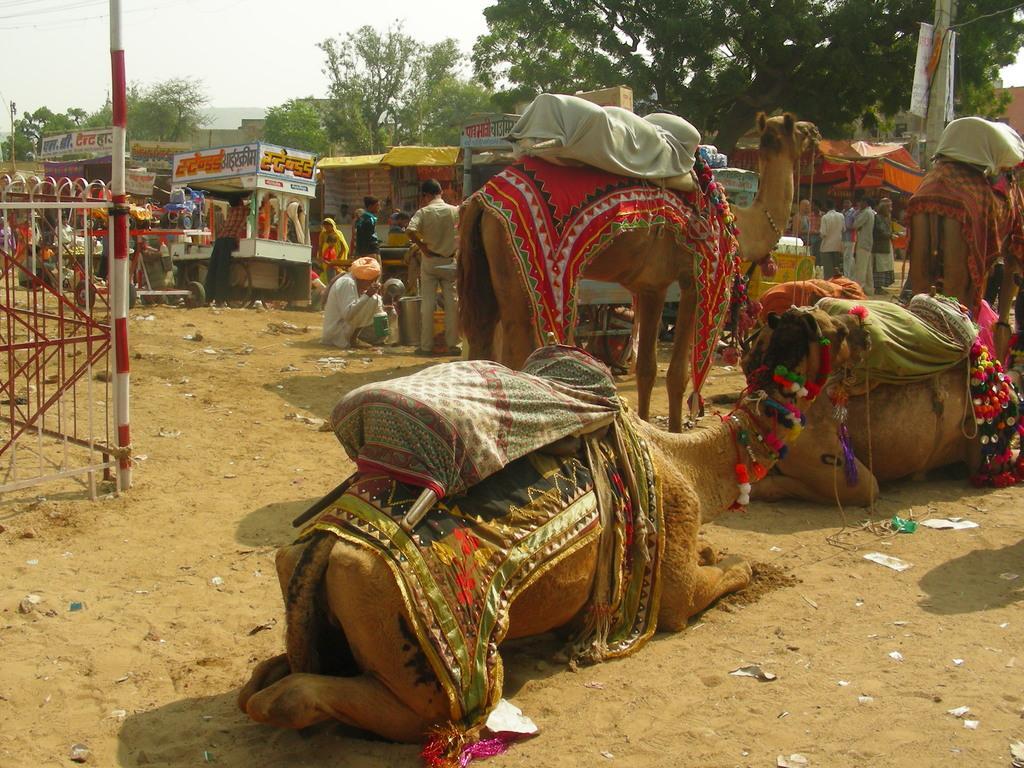In one or two sentences, can you explain what this image depicts? In the center of the image there are camels. In the background of the image there are stalls. There are trees. To the left side of the image there is a pole and metal grills. At the bottom of the image there is sand. 